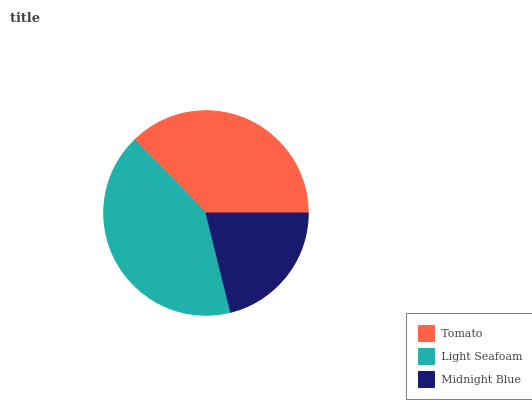Is Midnight Blue the minimum?
Answer yes or no. Yes. Is Light Seafoam the maximum?
Answer yes or no. Yes. Is Light Seafoam the minimum?
Answer yes or no. No. Is Midnight Blue the maximum?
Answer yes or no. No. Is Light Seafoam greater than Midnight Blue?
Answer yes or no. Yes. Is Midnight Blue less than Light Seafoam?
Answer yes or no. Yes. Is Midnight Blue greater than Light Seafoam?
Answer yes or no. No. Is Light Seafoam less than Midnight Blue?
Answer yes or no. No. Is Tomato the high median?
Answer yes or no. Yes. Is Tomato the low median?
Answer yes or no. Yes. Is Light Seafoam the high median?
Answer yes or no. No. Is Light Seafoam the low median?
Answer yes or no. No. 